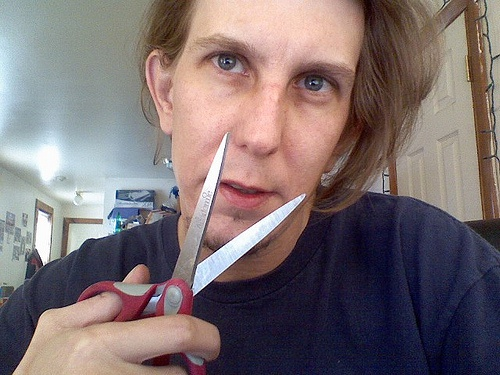Describe the objects in this image and their specific colors. I can see people in darkgray, black, tan, and gray tones, scissors in darkgray, lavender, brown, and gray tones, and chair in darkgray, black, and gray tones in this image. 